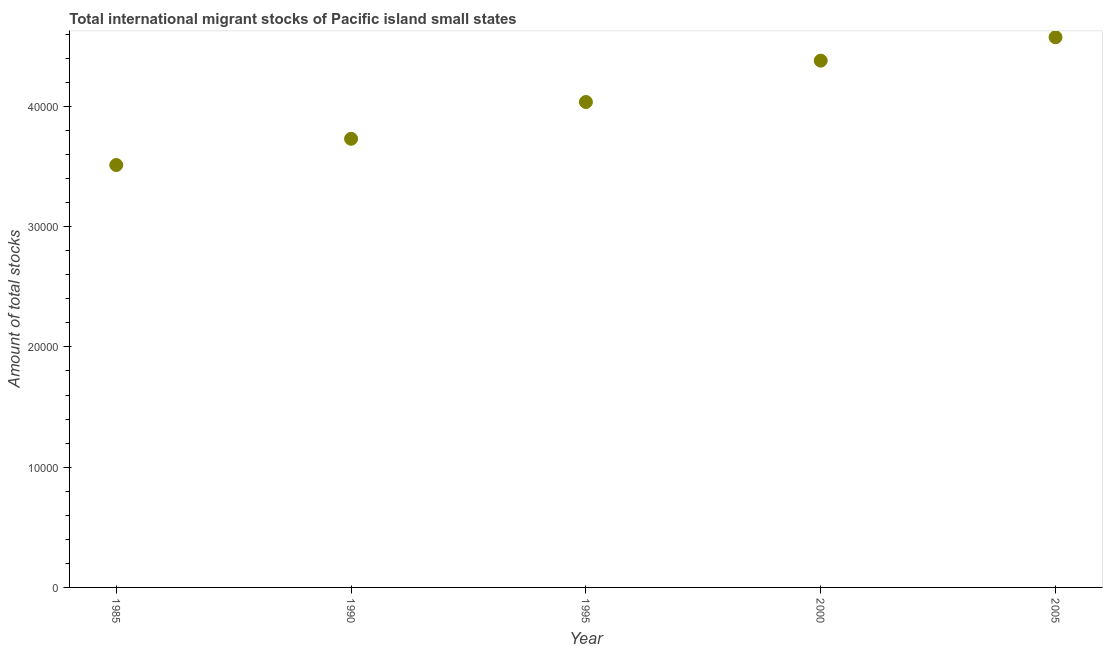What is the total number of international migrant stock in 1995?
Your response must be concise. 4.04e+04. Across all years, what is the maximum total number of international migrant stock?
Your response must be concise. 4.58e+04. Across all years, what is the minimum total number of international migrant stock?
Provide a short and direct response. 3.51e+04. What is the sum of the total number of international migrant stock?
Your answer should be very brief. 2.02e+05. What is the difference between the total number of international migrant stock in 1995 and 2005?
Provide a succinct answer. -5388. What is the average total number of international migrant stock per year?
Ensure brevity in your answer.  4.05e+04. What is the median total number of international migrant stock?
Your answer should be compact. 4.04e+04. What is the ratio of the total number of international migrant stock in 1990 to that in 2000?
Keep it short and to the point. 0.85. What is the difference between the highest and the second highest total number of international migrant stock?
Offer a terse response. 1950. Is the sum of the total number of international migrant stock in 1990 and 2005 greater than the maximum total number of international migrant stock across all years?
Your response must be concise. Yes. What is the difference between the highest and the lowest total number of international migrant stock?
Your answer should be compact. 1.06e+04. Does the total number of international migrant stock monotonically increase over the years?
Give a very brief answer. Yes. Are the values on the major ticks of Y-axis written in scientific E-notation?
Your answer should be compact. No. Does the graph contain any zero values?
Keep it short and to the point. No. What is the title of the graph?
Your answer should be very brief. Total international migrant stocks of Pacific island small states. What is the label or title of the Y-axis?
Your answer should be very brief. Amount of total stocks. What is the Amount of total stocks in 1985?
Offer a terse response. 3.51e+04. What is the Amount of total stocks in 1990?
Give a very brief answer. 3.73e+04. What is the Amount of total stocks in 1995?
Give a very brief answer. 4.04e+04. What is the Amount of total stocks in 2000?
Ensure brevity in your answer.  4.38e+04. What is the Amount of total stocks in 2005?
Provide a succinct answer. 4.58e+04. What is the difference between the Amount of total stocks in 1985 and 1990?
Your response must be concise. -2183. What is the difference between the Amount of total stocks in 1985 and 1995?
Provide a succinct answer. -5241. What is the difference between the Amount of total stocks in 1985 and 2000?
Your answer should be very brief. -8679. What is the difference between the Amount of total stocks in 1985 and 2005?
Give a very brief answer. -1.06e+04. What is the difference between the Amount of total stocks in 1990 and 1995?
Your answer should be compact. -3058. What is the difference between the Amount of total stocks in 1990 and 2000?
Make the answer very short. -6496. What is the difference between the Amount of total stocks in 1990 and 2005?
Your response must be concise. -8446. What is the difference between the Amount of total stocks in 1995 and 2000?
Give a very brief answer. -3438. What is the difference between the Amount of total stocks in 1995 and 2005?
Give a very brief answer. -5388. What is the difference between the Amount of total stocks in 2000 and 2005?
Keep it short and to the point. -1950. What is the ratio of the Amount of total stocks in 1985 to that in 1990?
Your answer should be compact. 0.94. What is the ratio of the Amount of total stocks in 1985 to that in 1995?
Keep it short and to the point. 0.87. What is the ratio of the Amount of total stocks in 1985 to that in 2000?
Offer a terse response. 0.8. What is the ratio of the Amount of total stocks in 1985 to that in 2005?
Provide a succinct answer. 0.77. What is the ratio of the Amount of total stocks in 1990 to that in 1995?
Your answer should be very brief. 0.92. What is the ratio of the Amount of total stocks in 1990 to that in 2000?
Provide a short and direct response. 0.85. What is the ratio of the Amount of total stocks in 1990 to that in 2005?
Your response must be concise. 0.81. What is the ratio of the Amount of total stocks in 1995 to that in 2000?
Make the answer very short. 0.92. What is the ratio of the Amount of total stocks in 1995 to that in 2005?
Keep it short and to the point. 0.88. What is the ratio of the Amount of total stocks in 2000 to that in 2005?
Your answer should be very brief. 0.96. 